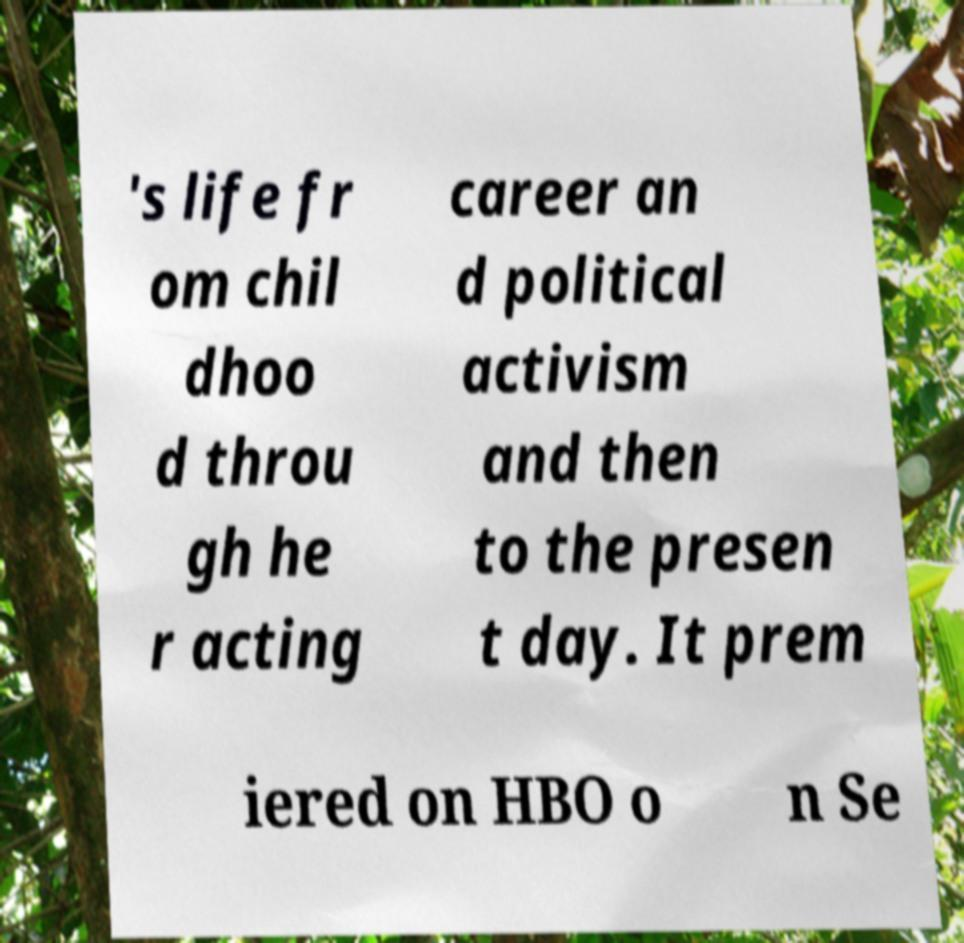Can you read and provide the text displayed in the image?This photo seems to have some interesting text. Can you extract and type it out for me? 's life fr om chil dhoo d throu gh he r acting career an d political activism and then to the presen t day. It prem iered on HBO o n Se 